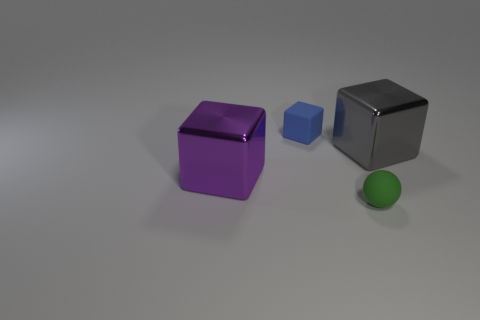There is a green object; does it have the same shape as the shiny object behind the large purple cube?
Your answer should be very brief. No. There is a object that is both right of the small blue matte object and in front of the gray metallic thing; how big is it?
Your response must be concise. Small. What is the color of the block that is in front of the tiny cube and on the left side of the large gray metallic thing?
Give a very brief answer. Purple. Are there any other things that are the same material as the small green ball?
Provide a short and direct response. Yes. Is the number of large purple shiny cubes behind the purple metallic object less than the number of cubes that are to the left of the small rubber sphere?
Offer a very short reply. Yes. Is there anything else that is the same color as the rubber block?
Provide a short and direct response. No. There is a green thing; what shape is it?
Your answer should be compact. Sphere. What color is the small sphere that is made of the same material as the small blue thing?
Your answer should be compact. Green. Is the number of small purple cylinders greater than the number of small green things?
Offer a very short reply. No. Are any small green spheres visible?
Your answer should be compact. Yes. 